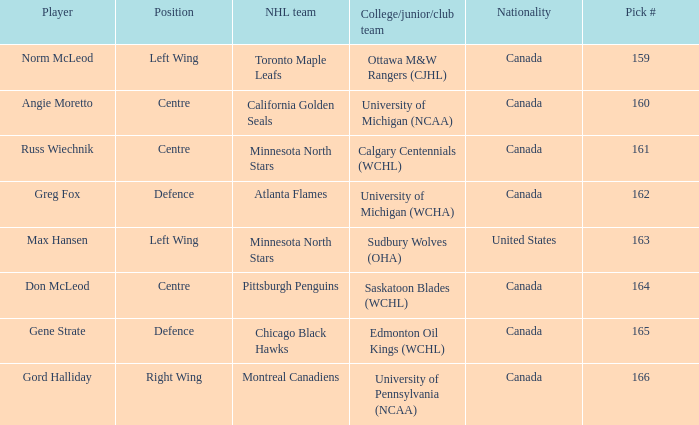What NHL team was the player from Calgary Centennials (WCHL) drafted for? Minnesota North Stars. 